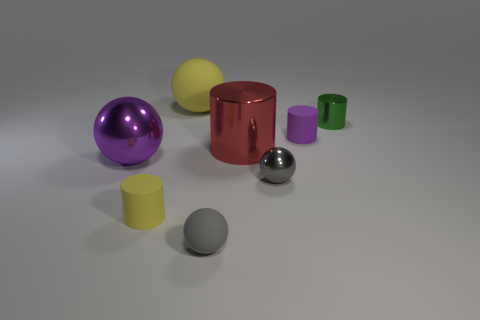Subtract all yellow matte cylinders. How many cylinders are left? 3 Subtract 3 cylinders. How many cylinders are left? 1 Add 1 small yellow matte things. How many objects exist? 9 Subtract all purple balls. How many balls are left? 3 Subtract all purple balls. Subtract all gray cubes. How many balls are left? 3 Subtract all green balls. How many brown cylinders are left? 0 Subtract all gray blocks. Subtract all green cylinders. How many objects are left? 7 Add 8 large metal spheres. How many large metal spheres are left? 9 Add 4 large objects. How many large objects exist? 7 Subtract 1 purple spheres. How many objects are left? 7 